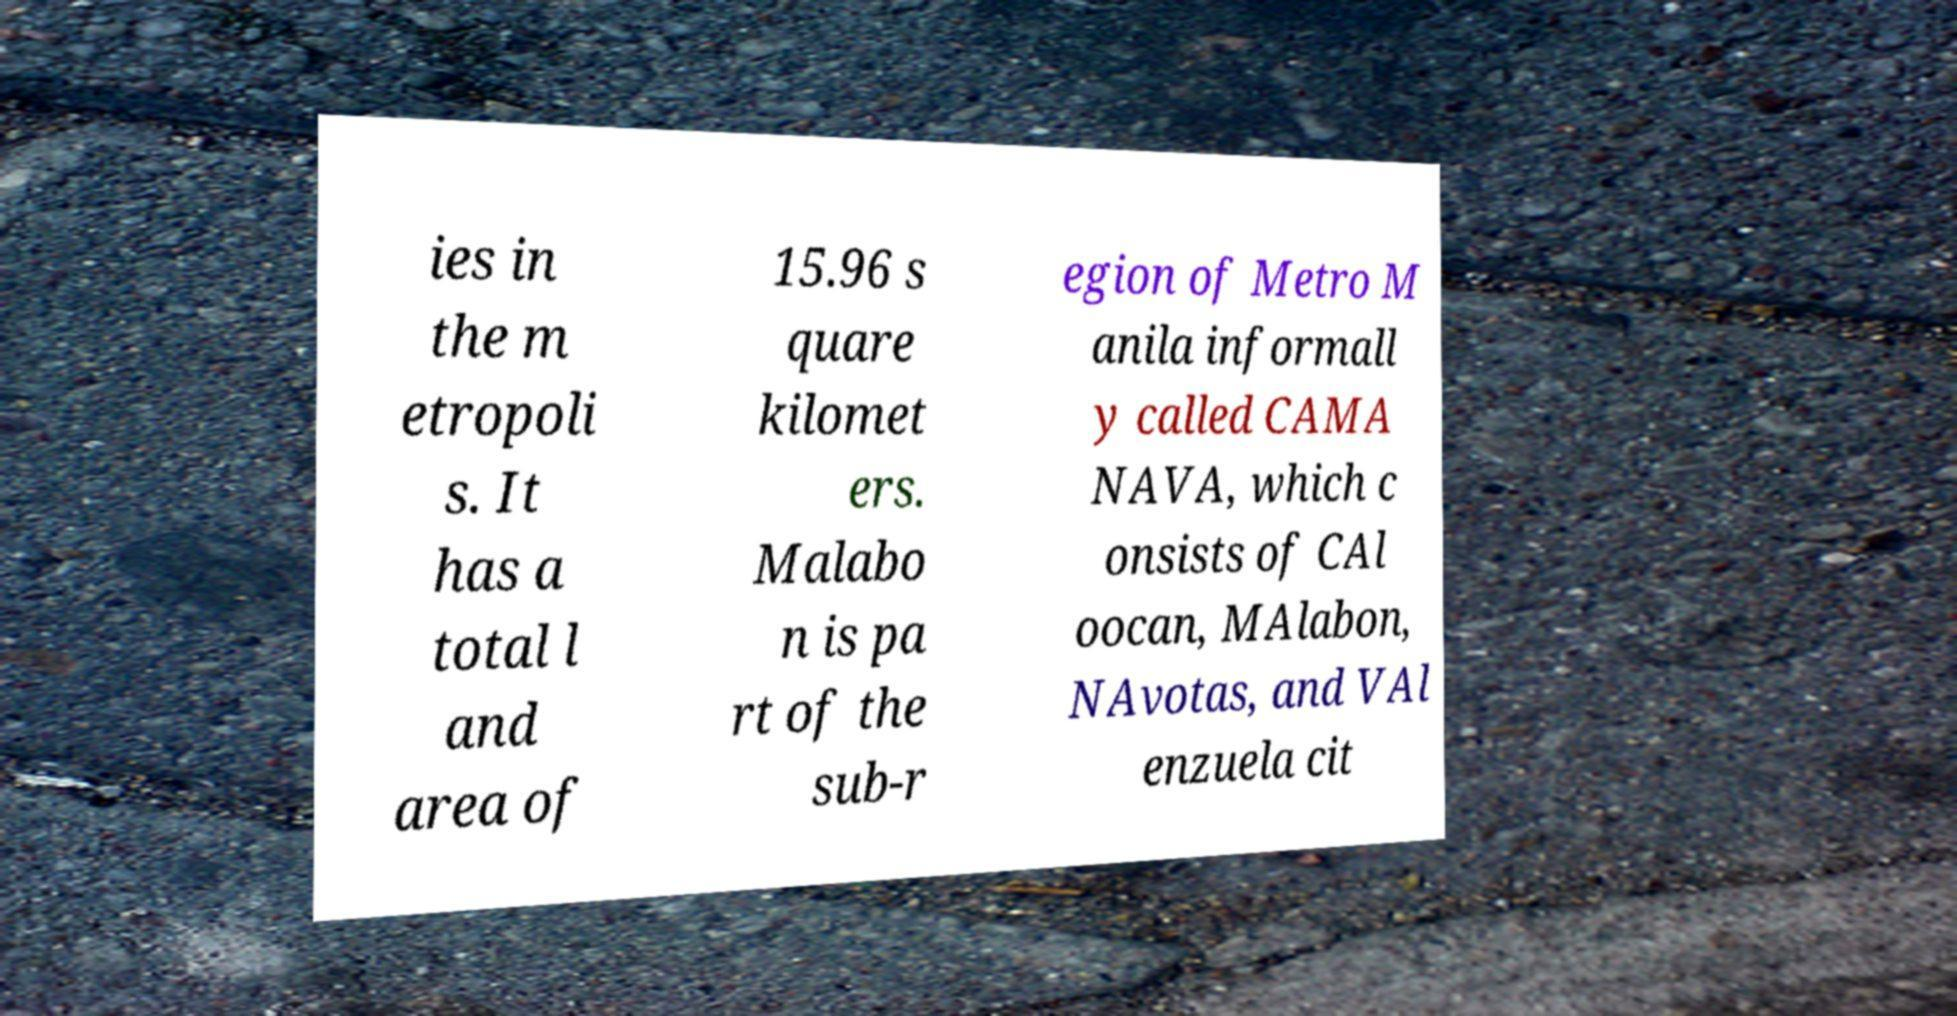For documentation purposes, I need the text within this image transcribed. Could you provide that? ies in the m etropoli s. It has a total l and area of 15.96 s quare kilomet ers. Malabo n is pa rt of the sub-r egion of Metro M anila informall y called CAMA NAVA, which c onsists of CAl oocan, MAlabon, NAvotas, and VAl enzuela cit 